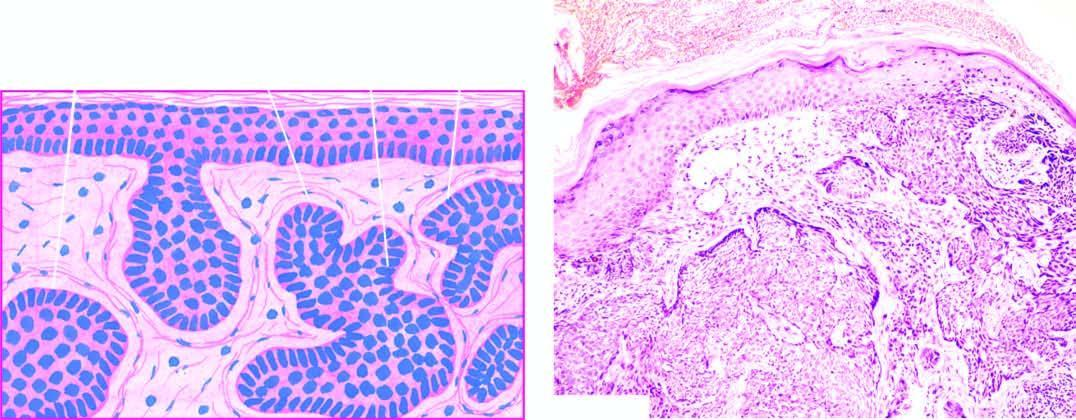re the masses of tumour cells separated from dermal collagen by a space called shrinkage artefact?
Answer the question using a single word or phrase. Yes 